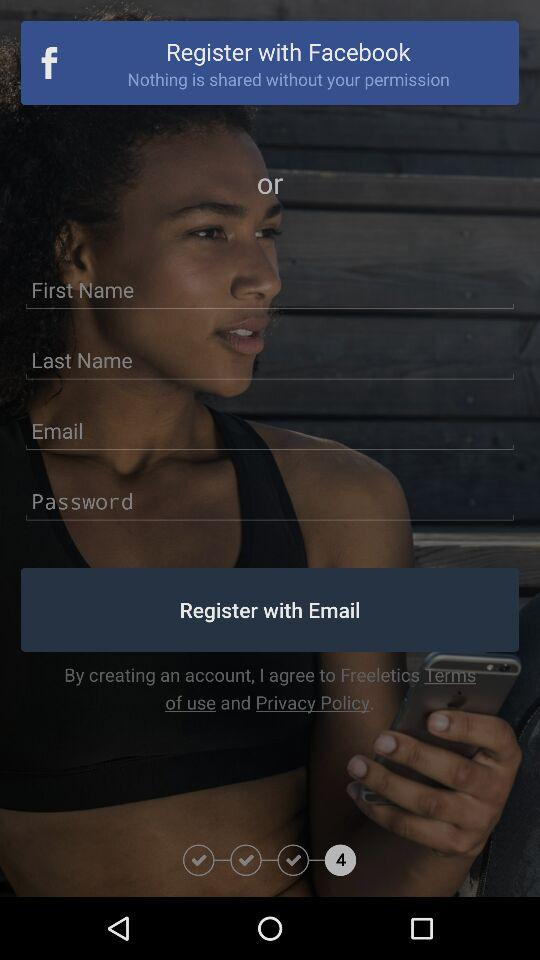What application can be used to register? The application "Facebook" can be used to register. 